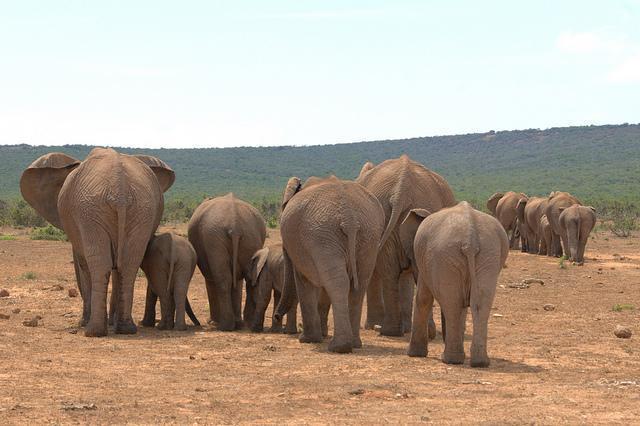How many elephants are visible?
Give a very brief answer. 7. 